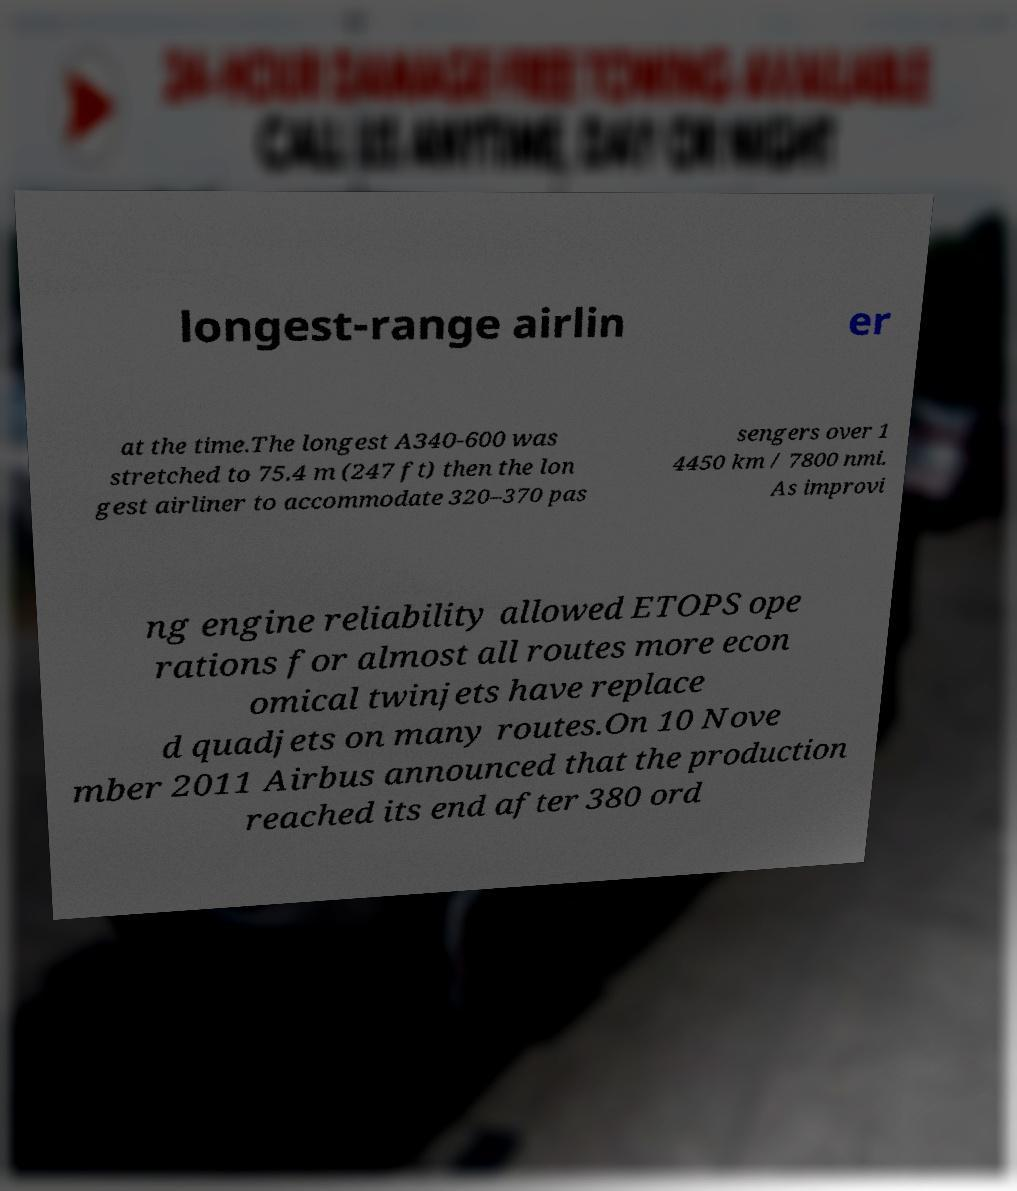What messages or text are displayed in this image? I need them in a readable, typed format. longest-range airlin er at the time.The longest A340-600 was stretched to 75.4 m (247 ft) then the lon gest airliner to accommodate 320–370 pas sengers over 1 4450 km / 7800 nmi. As improvi ng engine reliability allowed ETOPS ope rations for almost all routes more econ omical twinjets have replace d quadjets on many routes.On 10 Nove mber 2011 Airbus announced that the production reached its end after 380 ord 